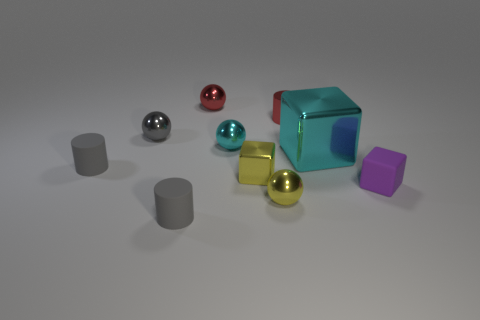What colors are the spheres in the image? The spheres in the image come in three colors: red, silver, and gold. 